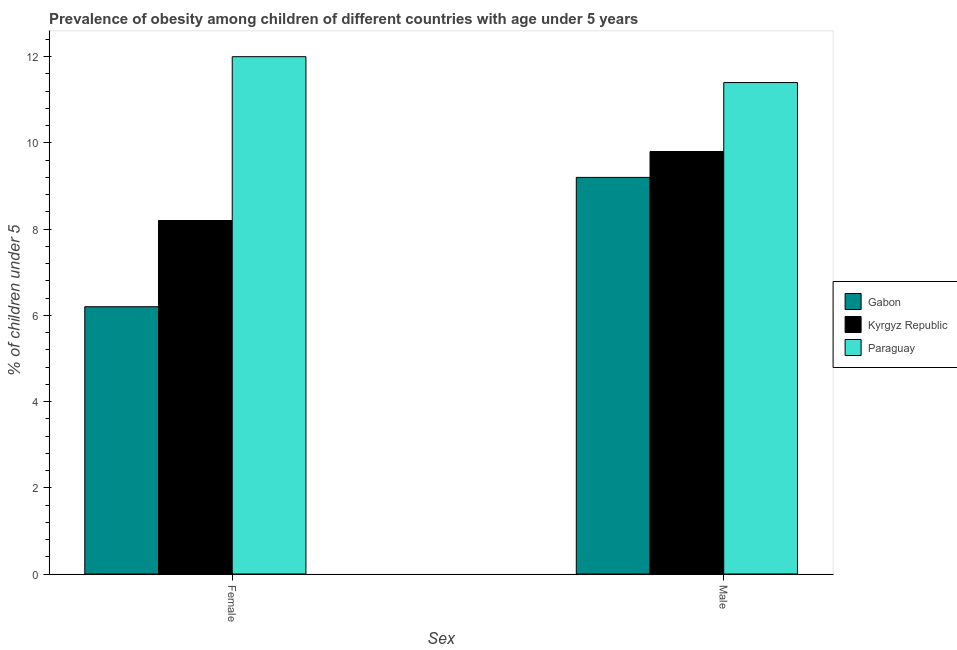How many different coloured bars are there?
Provide a succinct answer. 3. How many bars are there on the 2nd tick from the left?
Your answer should be compact. 3. What is the percentage of obese male children in Gabon?
Give a very brief answer. 9.2. Across all countries, what is the maximum percentage of obese female children?
Keep it short and to the point. 12. Across all countries, what is the minimum percentage of obese female children?
Offer a very short reply. 6.2. In which country was the percentage of obese female children maximum?
Provide a short and direct response. Paraguay. In which country was the percentage of obese male children minimum?
Keep it short and to the point. Gabon. What is the total percentage of obese male children in the graph?
Give a very brief answer. 30.4. What is the difference between the percentage of obese female children in Paraguay and that in Kyrgyz Republic?
Provide a short and direct response. 3.8. What is the difference between the percentage of obese female children in Kyrgyz Republic and the percentage of obese male children in Paraguay?
Your response must be concise. -3.2. What is the average percentage of obese female children per country?
Offer a terse response. 8.8. What is the difference between the percentage of obese female children and percentage of obese male children in Gabon?
Ensure brevity in your answer.  -3. What is the ratio of the percentage of obese female children in Kyrgyz Republic to that in Gabon?
Keep it short and to the point. 1.32. What does the 3rd bar from the left in Female represents?
Keep it short and to the point. Paraguay. What does the 3rd bar from the right in Male represents?
Your answer should be compact. Gabon. Are all the bars in the graph horizontal?
Keep it short and to the point. No. How many countries are there in the graph?
Give a very brief answer. 3. Are the values on the major ticks of Y-axis written in scientific E-notation?
Provide a succinct answer. No. Does the graph contain grids?
Your answer should be compact. No. What is the title of the graph?
Give a very brief answer. Prevalence of obesity among children of different countries with age under 5 years. Does "Channel Islands" appear as one of the legend labels in the graph?
Provide a succinct answer. No. What is the label or title of the X-axis?
Offer a terse response. Sex. What is the label or title of the Y-axis?
Provide a succinct answer.  % of children under 5. What is the  % of children under 5 in Gabon in Female?
Offer a very short reply. 6.2. What is the  % of children under 5 of Kyrgyz Republic in Female?
Your answer should be compact. 8.2. What is the  % of children under 5 of Paraguay in Female?
Your answer should be compact. 12. What is the  % of children under 5 of Gabon in Male?
Make the answer very short. 9.2. What is the  % of children under 5 in Kyrgyz Republic in Male?
Your response must be concise. 9.8. What is the  % of children under 5 in Paraguay in Male?
Make the answer very short. 11.4. Across all Sex, what is the maximum  % of children under 5 in Gabon?
Keep it short and to the point. 9.2. Across all Sex, what is the maximum  % of children under 5 in Kyrgyz Republic?
Keep it short and to the point. 9.8. Across all Sex, what is the minimum  % of children under 5 of Gabon?
Make the answer very short. 6.2. Across all Sex, what is the minimum  % of children under 5 of Kyrgyz Republic?
Give a very brief answer. 8.2. Across all Sex, what is the minimum  % of children under 5 of Paraguay?
Make the answer very short. 11.4. What is the total  % of children under 5 of Kyrgyz Republic in the graph?
Give a very brief answer. 18. What is the total  % of children under 5 in Paraguay in the graph?
Keep it short and to the point. 23.4. What is the difference between the  % of children under 5 in Gabon in Female and that in Male?
Your answer should be very brief. -3. What is the difference between the  % of children under 5 of Kyrgyz Republic in Female and that in Male?
Your answer should be compact. -1.6. What is the difference between the  % of children under 5 in Gabon in Female and the  % of children under 5 in Paraguay in Male?
Give a very brief answer. -5.2. What is the difference between the  % of children under 5 of Kyrgyz Republic in Female and the  % of children under 5 of Paraguay in Male?
Offer a terse response. -3.2. What is the average  % of children under 5 of Kyrgyz Republic per Sex?
Your answer should be compact. 9. What is the average  % of children under 5 of Paraguay per Sex?
Make the answer very short. 11.7. What is the difference between the  % of children under 5 of Kyrgyz Republic and  % of children under 5 of Paraguay in Female?
Your answer should be compact. -3.8. What is the difference between the  % of children under 5 of Gabon and  % of children under 5 of Kyrgyz Republic in Male?
Keep it short and to the point. -0.6. What is the ratio of the  % of children under 5 in Gabon in Female to that in Male?
Offer a terse response. 0.67. What is the ratio of the  % of children under 5 of Kyrgyz Republic in Female to that in Male?
Provide a short and direct response. 0.84. What is the ratio of the  % of children under 5 of Paraguay in Female to that in Male?
Your answer should be very brief. 1.05. What is the difference between the highest and the second highest  % of children under 5 of Gabon?
Offer a very short reply. 3. What is the difference between the highest and the second highest  % of children under 5 of Paraguay?
Provide a short and direct response. 0.6. 